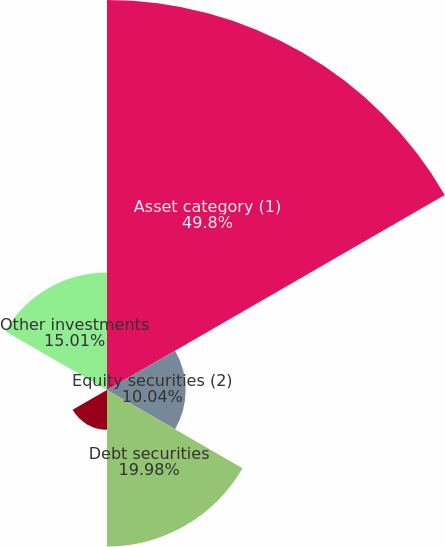Convert chart to OTSL. <chart><loc_0><loc_0><loc_500><loc_500><pie_chart><fcel>Asset category (1)<fcel>Equity securities (2)<fcel>Debt securities<fcel>Real estate<fcel>Private equity<fcel>Other investments<nl><fcel>49.8%<fcel>10.04%<fcel>19.98%<fcel>5.07%<fcel>0.1%<fcel>15.01%<nl></chart> 